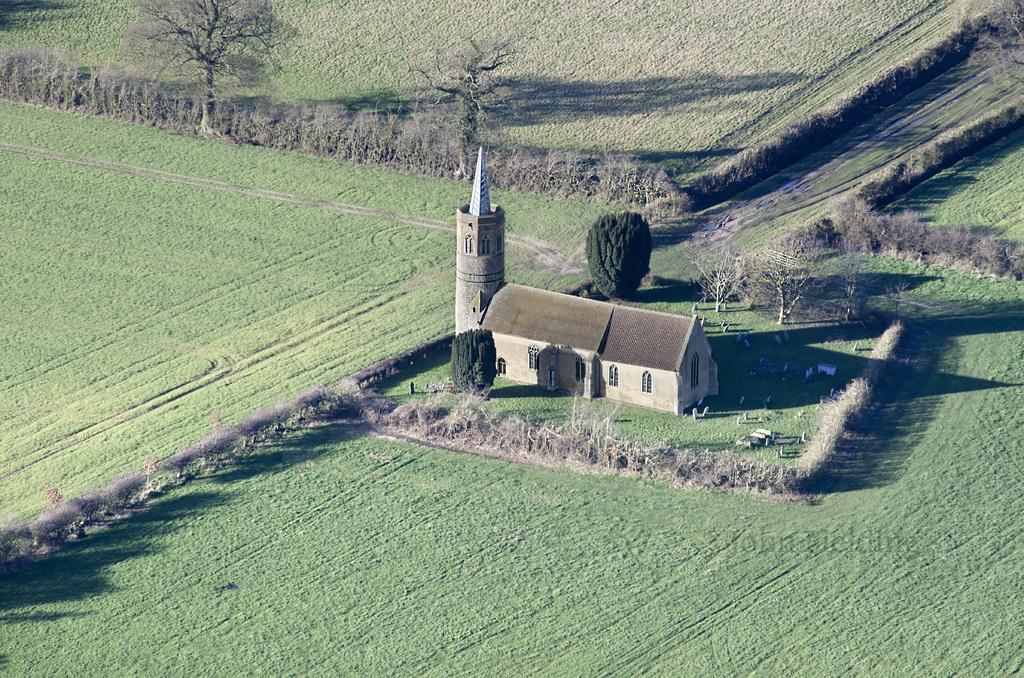What type of vegetation is at the bottom of the image? There is grass at the bottom of the image. What structure is located in the middle of the image? There is a house in the middle of the image. What can be seen in the background of the image? There are plants and trees in the background of the image. What type of page is being turned in the image? There is no page or book present in the image. What color is the flag flying in the background of the image? There is no flag present in the image. 